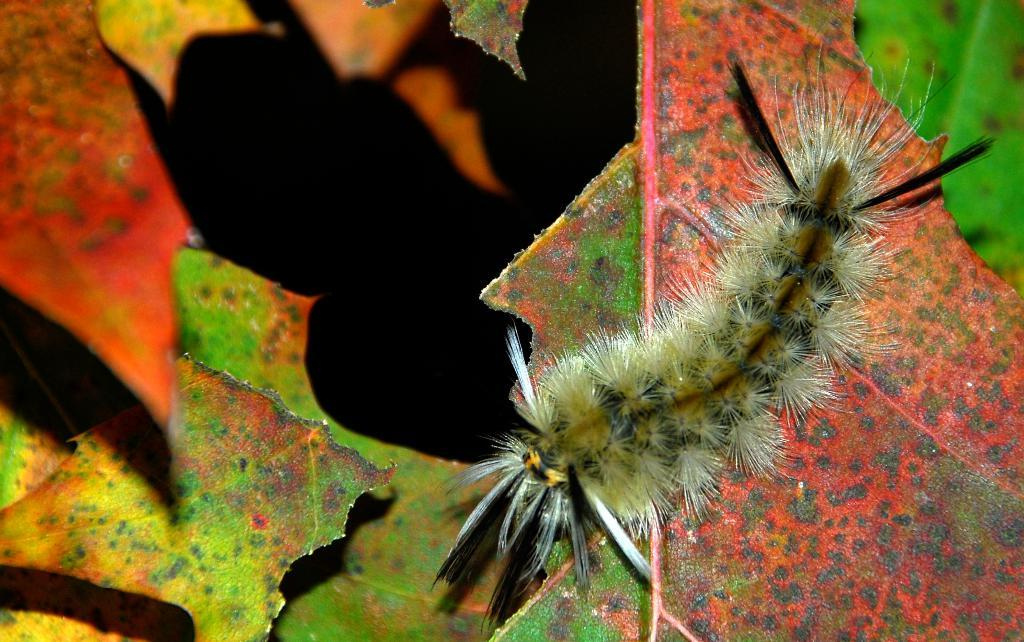What is the main subject of the image? The main subject of the image is a caterpillar on a leaf. Can you describe the setting of the image? The image features leaves at the bottom, which suggests a natural environment. How many lifts are visible in the image? There are no lifts present in the image; it features a caterpillar on a leaf in a natural environment. 